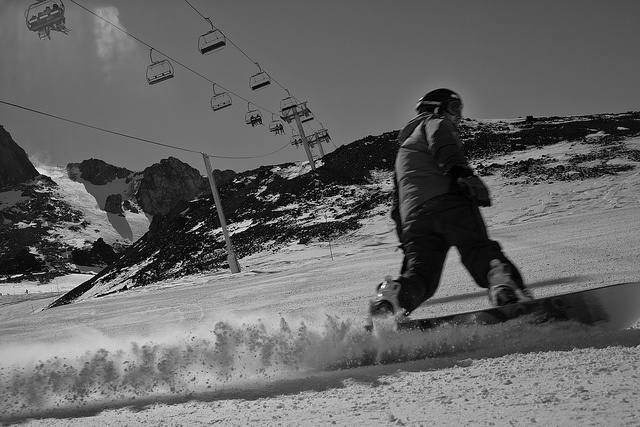Describe the objects in this image and their specific colors. I can see people in gray, black, and lightgray tones, snowboard in black and gray tones, people in black and gray tones, people in black and gray tones, and people in gray and black tones in this image. 